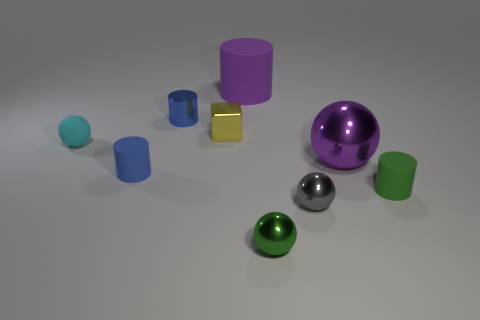Subtract all green cylinders. How many cylinders are left? 3 Subtract all green cylinders. How many cylinders are left? 3 Subtract all spheres. How many objects are left? 5 Subtract all green balls. Subtract all yellow cylinders. How many balls are left? 3 Subtract all yellow blocks. How many gray cylinders are left? 0 Subtract all green metal objects. Subtract all tiny yellow metal cylinders. How many objects are left? 8 Add 2 small metal cylinders. How many small metal cylinders are left? 3 Add 7 green cylinders. How many green cylinders exist? 8 Subtract 1 purple cylinders. How many objects are left? 8 Subtract 3 spheres. How many spheres are left? 1 